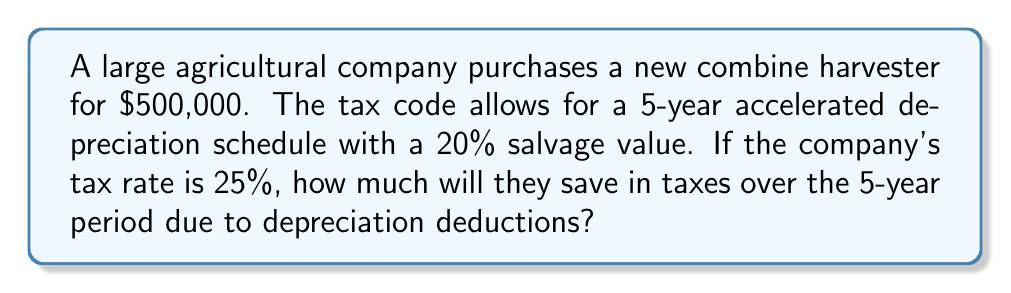Teach me how to tackle this problem. Let's approach this step-by-step:

1) First, calculate the depreciable amount:
   Total cost = $500,000
   Salvage value = 20% of $500,000 = $100,000
   Depreciable amount = $500,000 - $100,000 = $400,000

2) Calculate the annual depreciation:
   Depreciation period = 5 years
   Annual depreciation = $400,000 ÷ 5 = $80,000

3) Calculate the tax savings for each year:
   Annual tax savings = Annual depreciation × Tax rate
   Annual tax savings = $80,000 × 25% = $20,000

4) Calculate the total tax savings over 5 years:
   Total tax savings = Annual tax savings × 5 years
   Total tax savings = $20,000 × 5 = $100,000

Therefore, the company will save $100,000 in taxes over the 5-year period due to depreciation deductions.

This can be represented mathematically as:

$$\text{Tax Savings} = \frac{(\text{Cost} - \text{Salvage Value})}{\text{Depreciation Period}} \times \text{Tax Rate} \times \text{Depreciation Period}$$

$$\text{Tax Savings} = \frac{(\$500,000 - \$100,000)}{5} \times 0.25 \times 5 = \$100,000$$
Answer: $100,000 